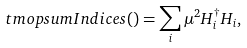Convert formula to latex. <formula><loc_0><loc_0><loc_500><loc_500>\ t m o p { s u m I n d i c e s ( ) } = \sum _ { i } \mu ^ { 2 } H _ { i } ^ { \dag } H _ { i } ,</formula> 